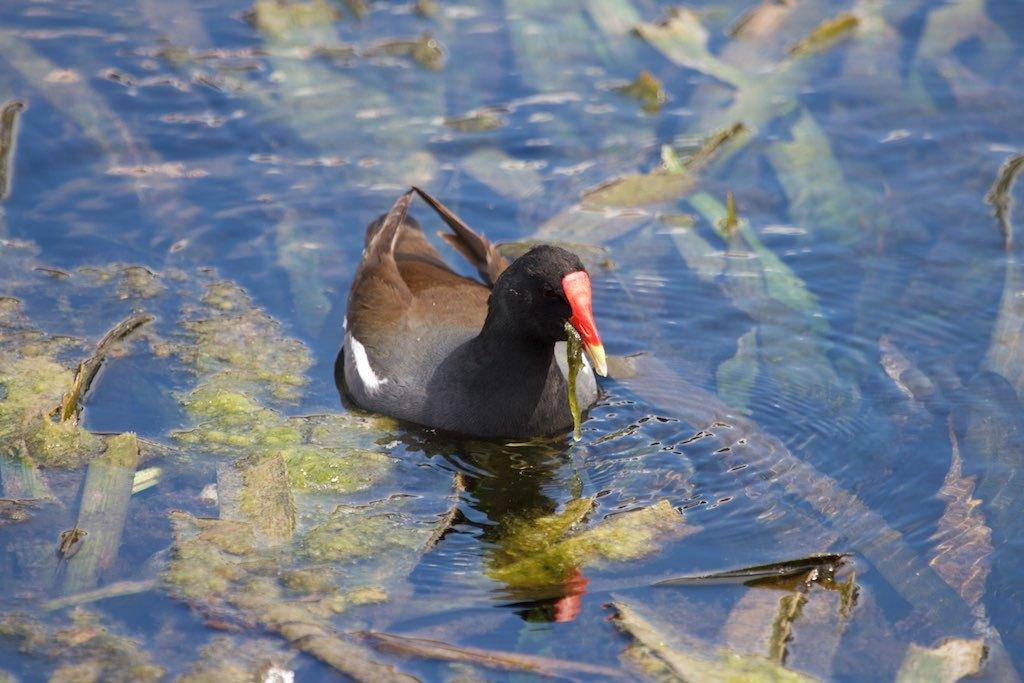What type of animal is in the image? There is a bird in the image. Where is the bird located? The bird is on the water. What else can be seen in the water in the image? There are objects inside the water in the image. What type of zebra can be seen offering a crook to the bird in the image? There is no zebra or crook present in the image; it features a bird on the water with objects inside the water. 